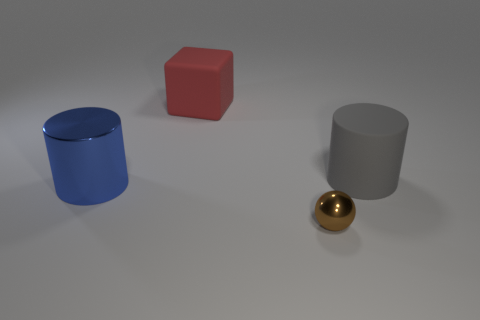Add 3 big blue cylinders. How many objects exist? 7 Subtract all balls. How many objects are left? 3 Add 2 gray matte cylinders. How many gray matte cylinders exist? 3 Subtract 0 yellow blocks. How many objects are left? 4 Subtract all red matte blocks. Subtract all tiny brown rubber objects. How many objects are left? 3 Add 3 tiny objects. How many tiny objects are left? 4 